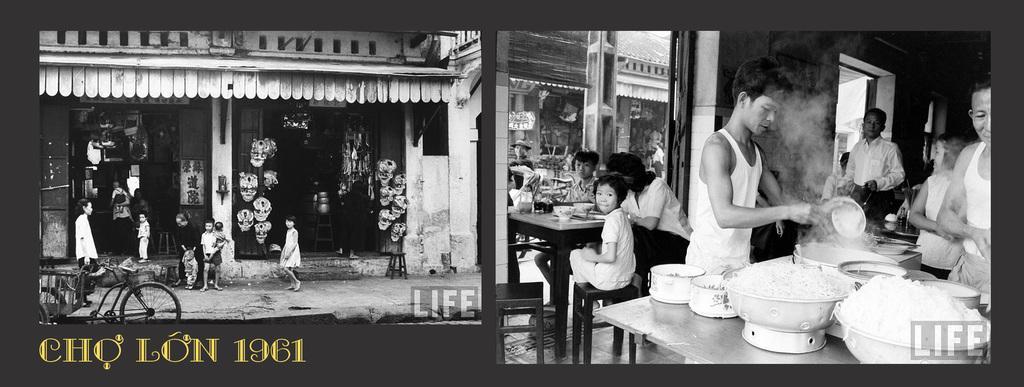Describe this image in one or two sentences. This image consists of many people. On the right, there is food kept on the table. On the left, we can see shops. And there are children walking on the road. At the bottom, there is a text. In the background, there are buildings. 